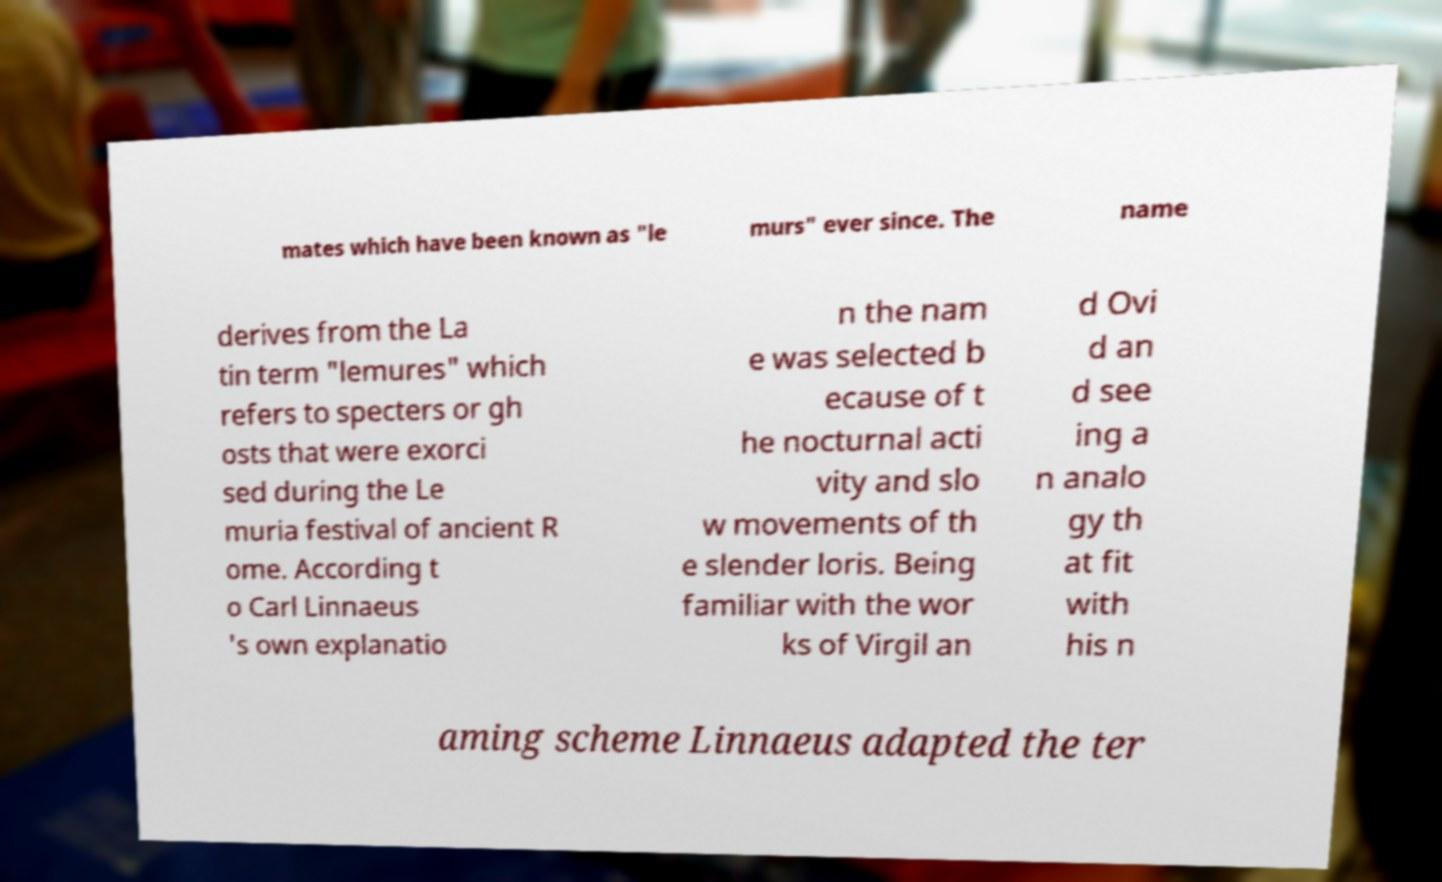For documentation purposes, I need the text within this image transcribed. Could you provide that? mates which have been known as "le murs" ever since. The name derives from the La tin term "lemures" which refers to specters or gh osts that were exorci sed during the Le muria festival of ancient R ome. According t o Carl Linnaeus 's own explanatio n the nam e was selected b ecause of t he nocturnal acti vity and slo w movements of th e slender loris. Being familiar with the wor ks of Virgil an d Ovi d an d see ing a n analo gy th at fit with his n aming scheme Linnaeus adapted the ter 